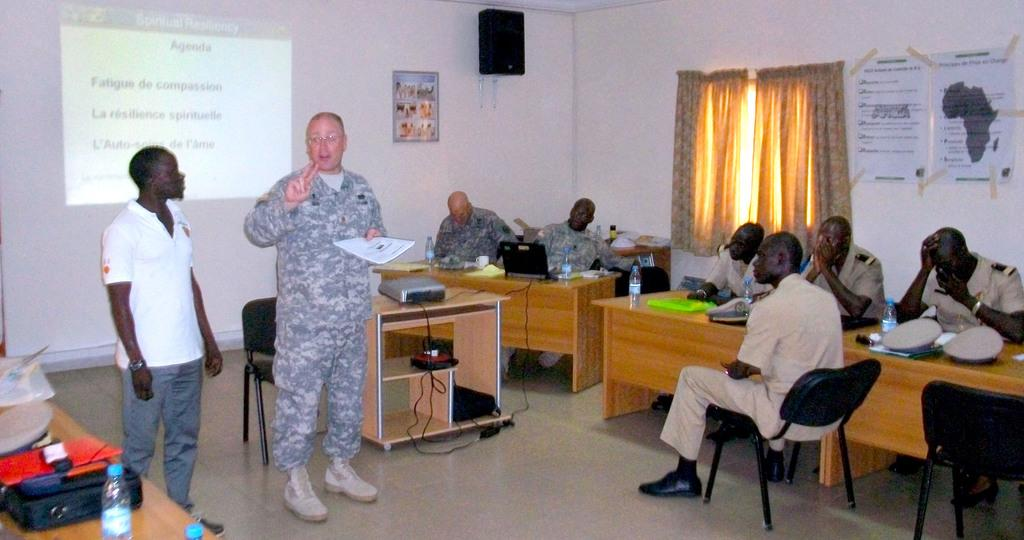<image>
Give a short and clear explanation of the subsequent image. a meeting between a military and African group with an Agenda sign on the wall. 